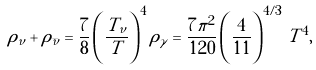<formula> <loc_0><loc_0><loc_500><loc_500>\rho _ { \nu } + \rho _ { \bar { \nu } } = \frac { 7 } { 8 } \left ( \frac { T _ { \nu } } { T } \right ) ^ { 4 } \rho _ { \gamma } = \frac { 7 \pi ^ { 2 } } { 1 2 0 } \left ( \frac { 4 } { 1 1 } \right ) ^ { 4 / 3 } \, T ^ { 4 } ,</formula> 